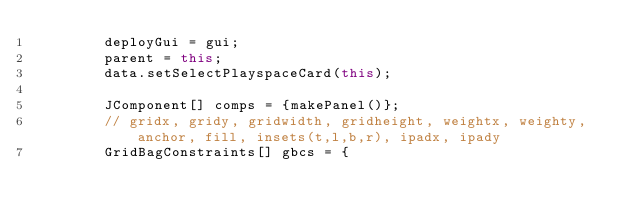Convert code to text. <code><loc_0><loc_0><loc_500><loc_500><_Java_>		deployGui = gui;
		parent = this;
		data.setSelectPlayspaceCard(this);

		JComponent[] comps = {makePanel()};
		// gridx, gridy, gridwidth, gridheight, weightx, weighty, anchor, fill, insets(t,l,b,r), ipadx, ipady
		GridBagConstraints[] gbcs = {</code> 